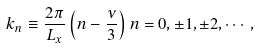Convert formula to latex. <formula><loc_0><loc_0><loc_500><loc_500>k _ { n } \equiv \frac { 2 \pi } { L _ { x } } \left ( n - \frac { \nu } { 3 } \right ) n = 0 , \pm 1 , \pm 2 , \cdots ,</formula> 